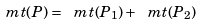Convert formula to latex. <formula><loc_0><loc_0><loc_500><loc_500>\ m t ( P ) = \ m t ( P _ { 1 } ) + \ m t ( P _ { 2 } )</formula> 